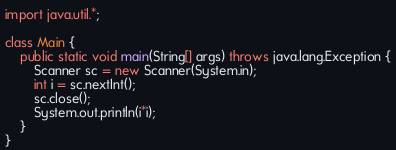Convert code to text. <code><loc_0><loc_0><loc_500><loc_500><_Java_>import java.util.*;

class Main {
    public static void main(String[] args) throws java.lang.Exception {
        Scanner sc = new Scanner(System.in);
        int i = sc.nextInt();
        sc.close();
        System.out.println(i*i);
    }
}
</code> 